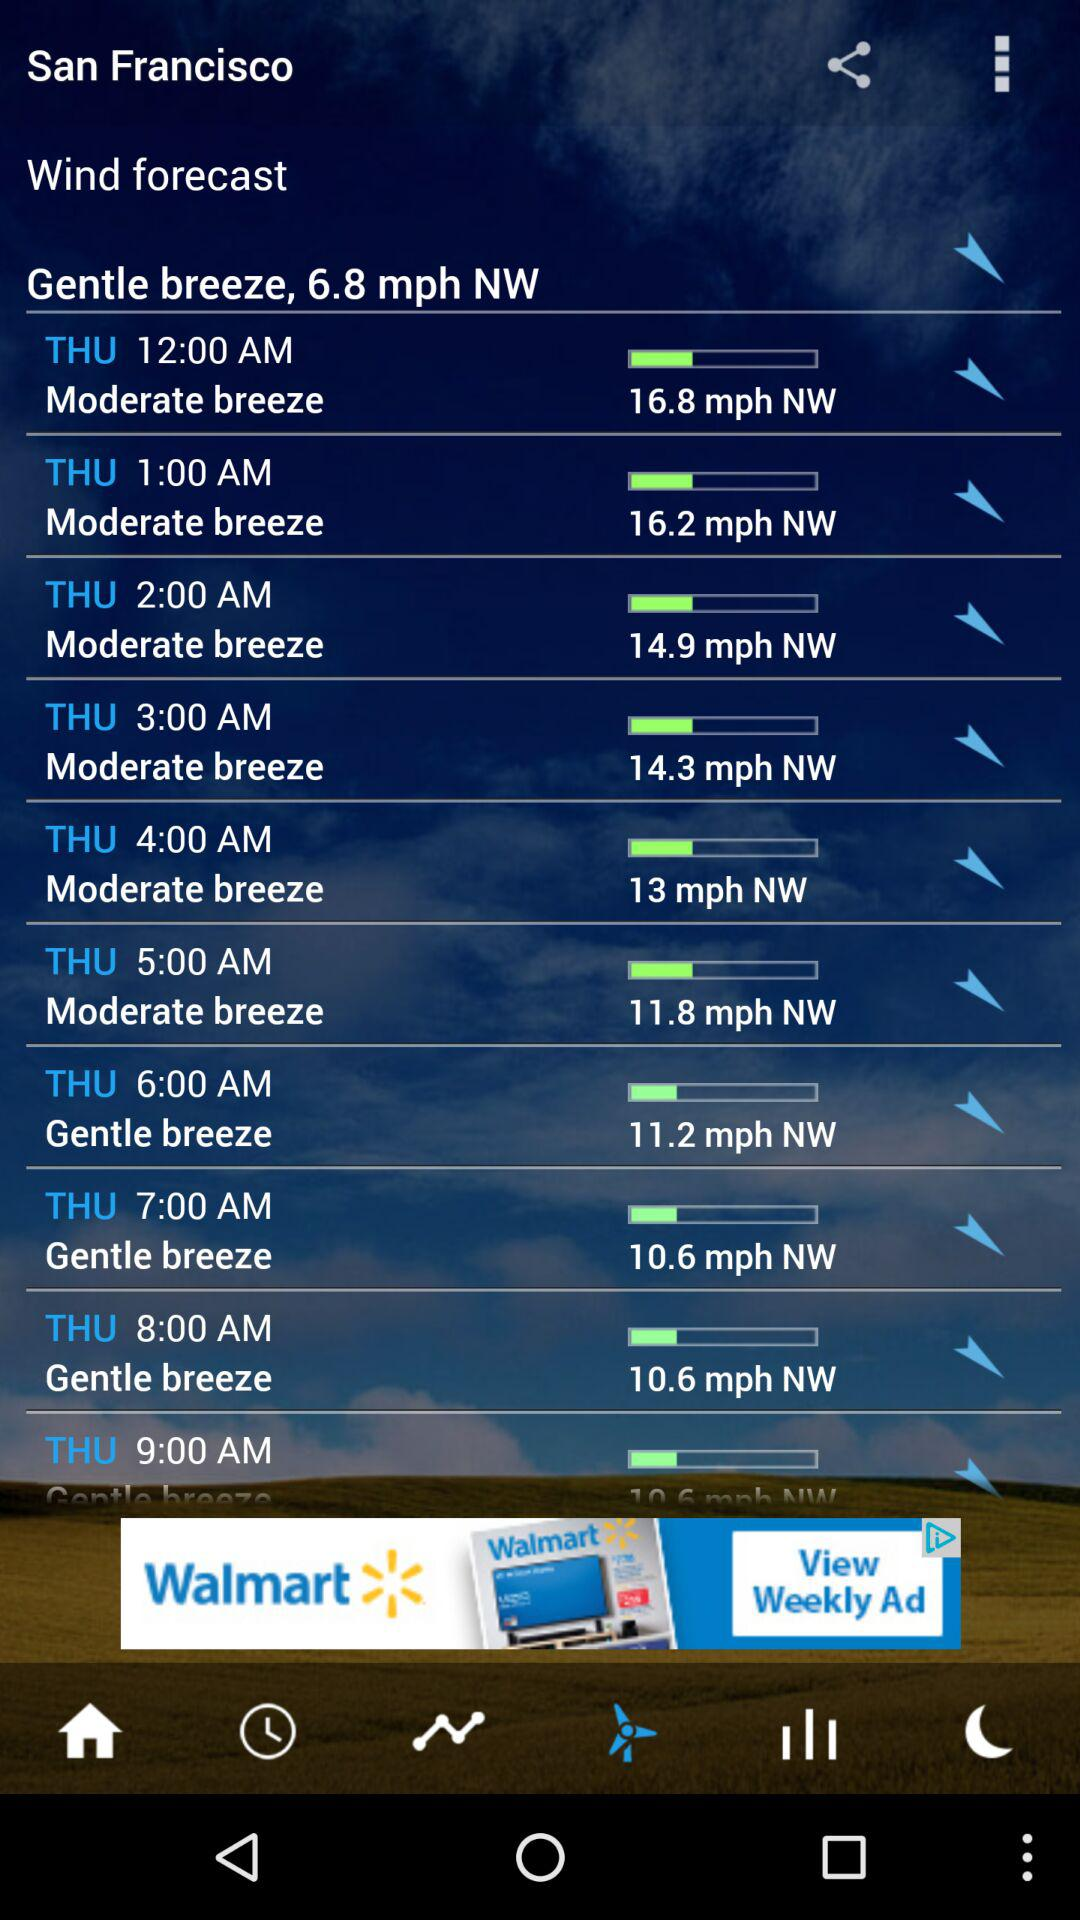What is the wind speed on Thursday at 12:00 a.m.? The wind speed is 16.8 mph. 